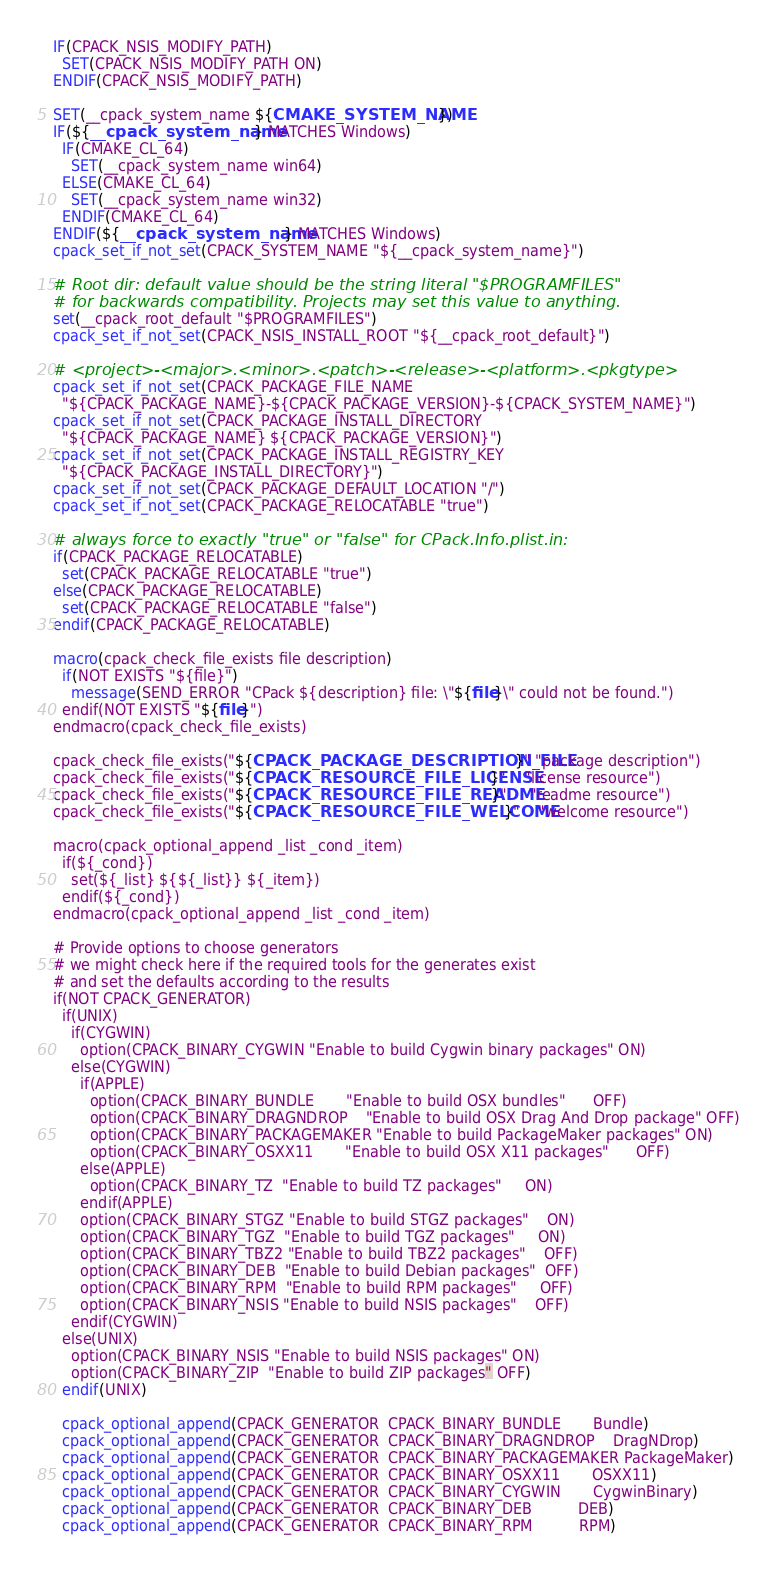Convert code to text. <code><loc_0><loc_0><loc_500><loc_500><_CMake_>IF(CPACK_NSIS_MODIFY_PATH)
  SET(CPACK_NSIS_MODIFY_PATH ON)
ENDIF(CPACK_NSIS_MODIFY_PATH)

SET(__cpack_system_name ${CMAKE_SYSTEM_NAME})
IF(${__cpack_system_name} MATCHES Windows)
  IF(CMAKE_CL_64)
    SET(__cpack_system_name win64)
  ELSE(CMAKE_CL_64)
    SET(__cpack_system_name win32)
  ENDIF(CMAKE_CL_64)
ENDIF(${__cpack_system_name} MATCHES Windows)
cpack_set_if_not_set(CPACK_SYSTEM_NAME "${__cpack_system_name}")

# Root dir: default value should be the string literal "$PROGRAMFILES"
# for backwards compatibility. Projects may set this value to anything.
set(__cpack_root_default "$PROGRAMFILES")
cpack_set_if_not_set(CPACK_NSIS_INSTALL_ROOT "${__cpack_root_default}")

# <project>-<major>.<minor>.<patch>-<release>-<platform>.<pkgtype>
cpack_set_if_not_set(CPACK_PACKAGE_FILE_NAME
  "${CPACK_PACKAGE_NAME}-${CPACK_PACKAGE_VERSION}-${CPACK_SYSTEM_NAME}")
cpack_set_if_not_set(CPACK_PACKAGE_INSTALL_DIRECTORY
  "${CPACK_PACKAGE_NAME} ${CPACK_PACKAGE_VERSION}")
cpack_set_if_not_set(CPACK_PACKAGE_INSTALL_REGISTRY_KEY
  "${CPACK_PACKAGE_INSTALL_DIRECTORY}")
cpack_set_if_not_set(CPACK_PACKAGE_DEFAULT_LOCATION "/")
cpack_set_if_not_set(CPACK_PACKAGE_RELOCATABLE "true")

# always force to exactly "true" or "false" for CPack.Info.plist.in:
if(CPACK_PACKAGE_RELOCATABLE)
  set(CPACK_PACKAGE_RELOCATABLE "true")
else(CPACK_PACKAGE_RELOCATABLE)
  set(CPACK_PACKAGE_RELOCATABLE "false")
endif(CPACK_PACKAGE_RELOCATABLE)

macro(cpack_check_file_exists file description)
  if(NOT EXISTS "${file}")
    message(SEND_ERROR "CPack ${description} file: \"${file}\" could not be found.")
  endif(NOT EXISTS "${file}")
endmacro(cpack_check_file_exists)

cpack_check_file_exists("${CPACK_PACKAGE_DESCRIPTION_FILE}" "package description")
cpack_check_file_exists("${CPACK_RESOURCE_FILE_LICENSE}"    "license resource")
cpack_check_file_exists("${CPACK_RESOURCE_FILE_README}"     "readme resource")
cpack_check_file_exists("${CPACK_RESOURCE_FILE_WELCOME}"    "welcome resource")

macro(cpack_optional_append _list _cond _item)
  if(${_cond})
    set(${_list} ${${_list}} ${_item})
  endif(${_cond})
endmacro(cpack_optional_append _list _cond _item)

# Provide options to choose generators
# we might check here if the required tools for the generates exist
# and set the defaults according to the results
if(NOT CPACK_GENERATOR)
  if(UNIX)
    if(CYGWIN)
      option(CPACK_BINARY_CYGWIN "Enable to build Cygwin binary packages" ON)
    else(CYGWIN)
      if(APPLE)
        option(CPACK_BINARY_BUNDLE       "Enable to build OSX bundles"      OFF)
        option(CPACK_BINARY_DRAGNDROP    "Enable to build OSX Drag And Drop package" OFF)
        option(CPACK_BINARY_PACKAGEMAKER "Enable to build PackageMaker packages" ON)
        option(CPACK_BINARY_OSXX11       "Enable to build OSX X11 packages"      OFF)
      else(APPLE)
        option(CPACK_BINARY_TZ  "Enable to build TZ packages"     ON)
      endif(APPLE)
      option(CPACK_BINARY_STGZ "Enable to build STGZ packages"    ON)
      option(CPACK_BINARY_TGZ  "Enable to build TGZ packages"     ON)
      option(CPACK_BINARY_TBZ2 "Enable to build TBZ2 packages"    OFF)
      option(CPACK_BINARY_DEB  "Enable to build Debian packages"  OFF)
      option(CPACK_BINARY_RPM  "Enable to build RPM packages"     OFF)
      option(CPACK_BINARY_NSIS "Enable to build NSIS packages"    OFF)
    endif(CYGWIN)
  else(UNIX)
    option(CPACK_BINARY_NSIS "Enable to build NSIS packages" ON)
    option(CPACK_BINARY_ZIP  "Enable to build ZIP packages" OFF)
  endif(UNIX)
  
  cpack_optional_append(CPACK_GENERATOR  CPACK_BINARY_BUNDLE       Bundle)
  cpack_optional_append(CPACK_GENERATOR  CPACK_BINARY_DRAGNDROP    DragNDrop)
  cpack_optional_append(CPACK_GENERATOR  CPACK_BINARY_PACKAGEMAKER PackageMaker)
  cpack_optional_append(CPACK_GENERATOR  CPACK_BINARY_OSXX11       OSXX11)
  cpack_optional_append(CPACK_GENERATOR  CPACK_BINARY_CYGWIN       CygwinBinary)
  cpack_optional_append(CPACK_GENERATOR  CPACK_BINARY_DEB          DEB)
  cpack_optional_append(CPACK_GENERATOR  CPACK_BINARY_RPM          RPM)</code> 